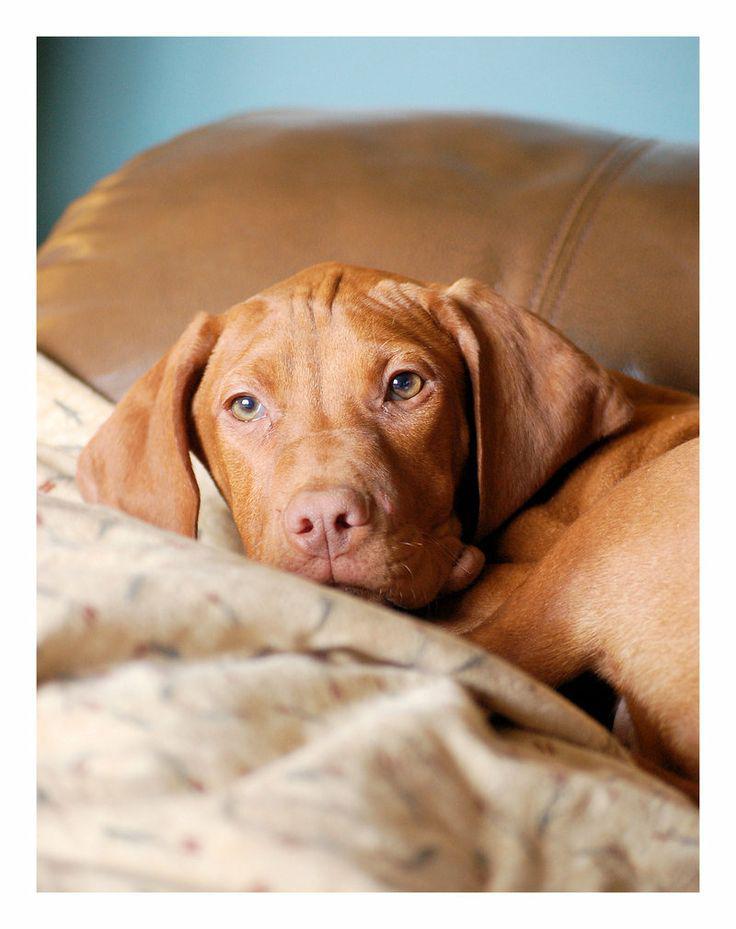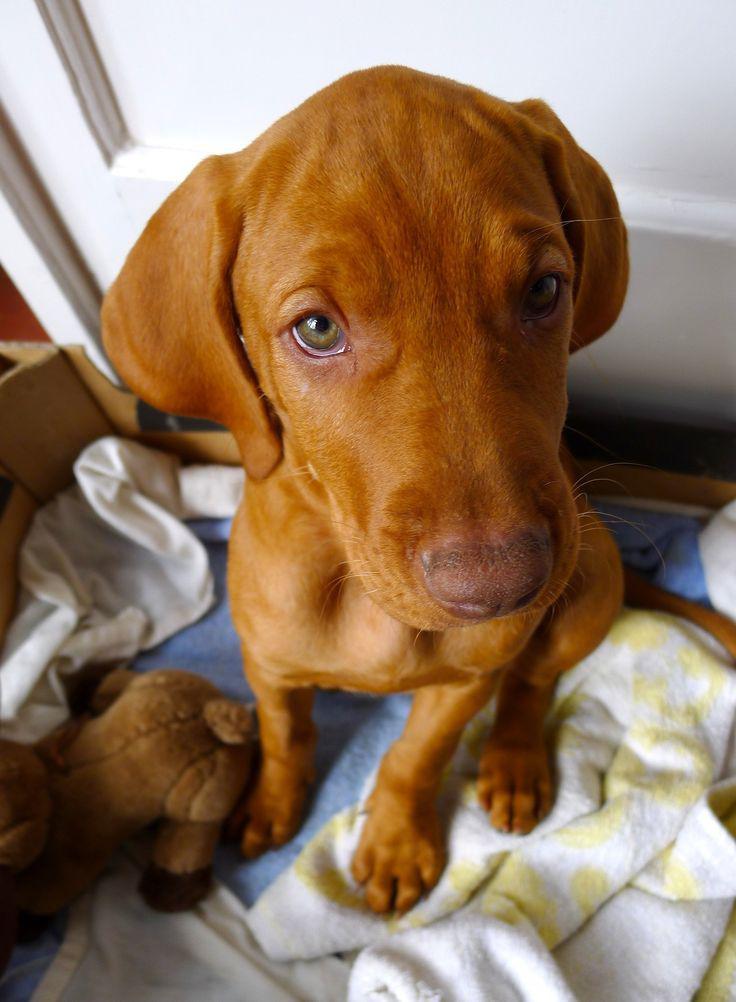The first image is the image on the left, the second image is the image on the right. Considering the images on both sides, is "A Vizsla dog is lying on a blanket." valid? Answer yes or no. Yes. The first image is the image on the left, the second image is the image on the right. For the images shown, is this caption "Each image contains a single red-orange dog, and the right image contains an upward-gazing dog in a sitting pose with a toy stuffed animal by one foot." true? Answer yes or no. Yes. 